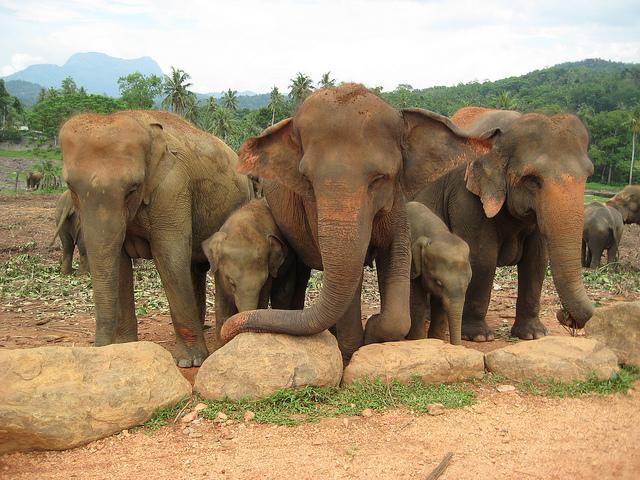Do the elephants have dirt on them?
Keep it brief. Yes. Where are the baby elephants?
Keep it brief. Between big elephants. Are these all the same species of elephants?
Be succinct. Yes. 